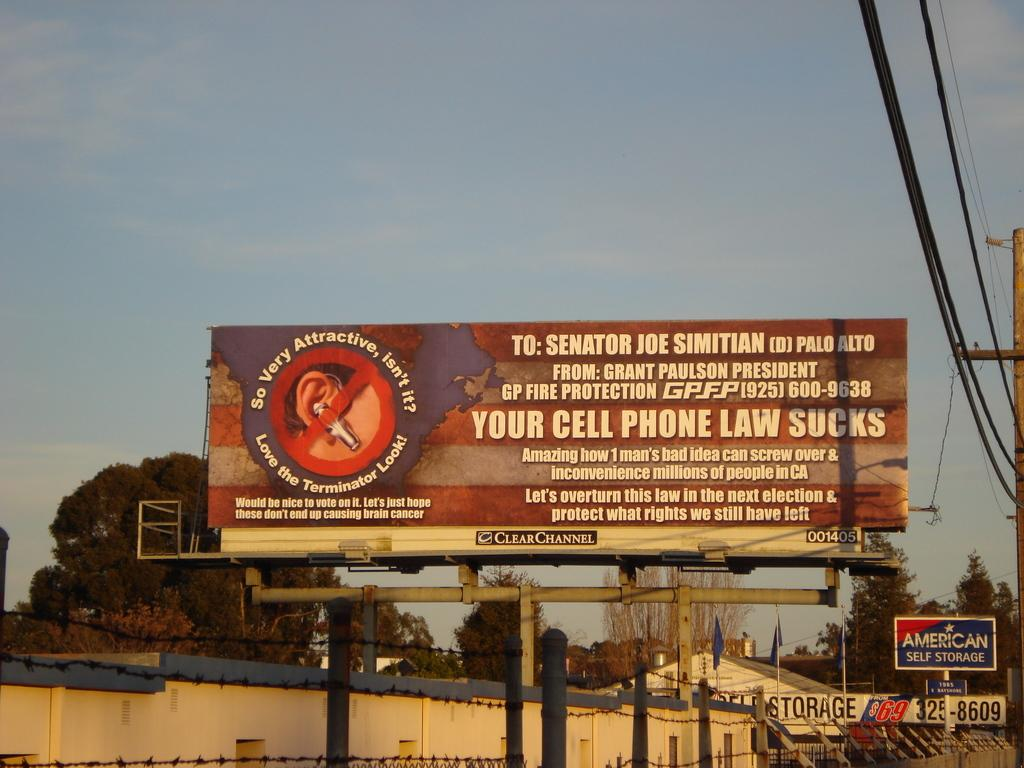<image>
Describe the image concisely. A ROADSIDE BILLBOARD REGARDING CELL PHONE USAGE LAWS 